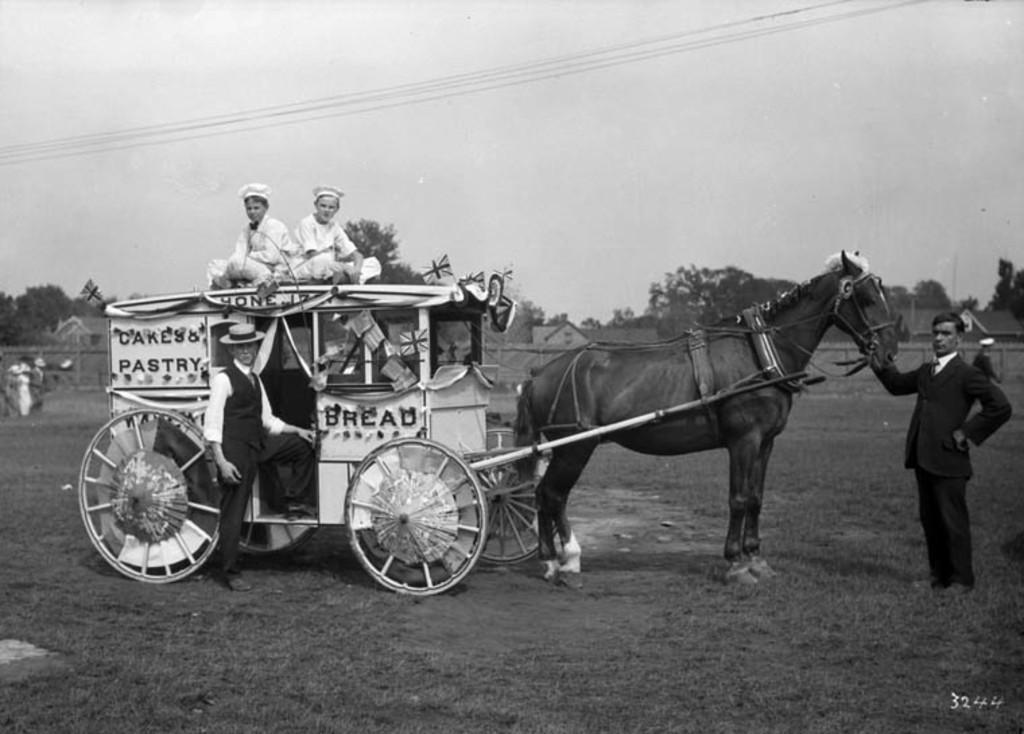Please provide a concise description of this image. This is the picture of a bullock cart in which there are some people and a person in front of the horse. 